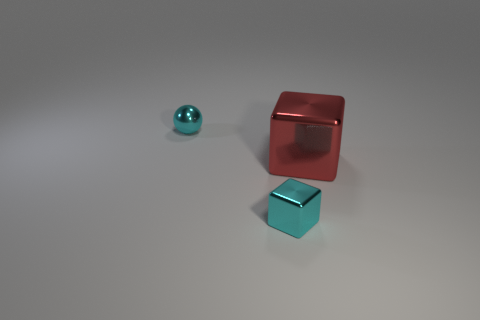Are there any tiny shiny things that have the same color as the shiny sphere?
Provide a short and direct response. Yes. Is there anything else that is the same size as the red block?
Provide a short and direct response. No. What size is the shiny block that is behind the tiny cyan thing that is in front of the big red metallic object?
Your answer should be very brief. Large. What number of big things are brown metal balls or cyan metallic cubes?
Make the answer very short. 0. How many other objects are the same color as the big cube?
Your response must be concise. 0. There is a cyan thing that is on the right side of the small cyan ball; does it have the same size as the metallic thing behind the red block?
Offer a very short reply. Yes. Does the large red cube have the same material as the cyan ball behind the big red metallic cube?
Your answer should be compact. Yes. Is the number of cyan metallic spheres that are in front of the cyan shiny ball greater than the number of small metal things right of the small cyan cube?
Your response must be concise. No. The small object that is right of the cyan object behind the small cyan cube is what color?
Your answer should be compact. Cyan. What number of blocks are cyan metal objects or metallic objects?
Keep it short and to the point. 2. 